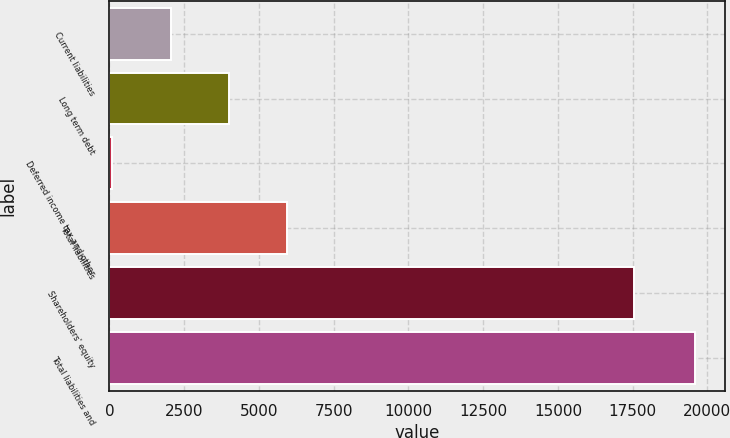Convert chart to OTSL. <chart><loc_0><loc_0><loc_500><loc_500><bar_chart><fcel>Current liabilities<fcel>Long term debt<fcel>Deferred income tax and other<fcel>Total liabilities<fcel>Shareholders' equity<fcel>Total liabilities and<nl><fcel>2051<fcel>4001<fcel>101<fcel>5951<fcel>17561<fcel>19601<nl></chart> 